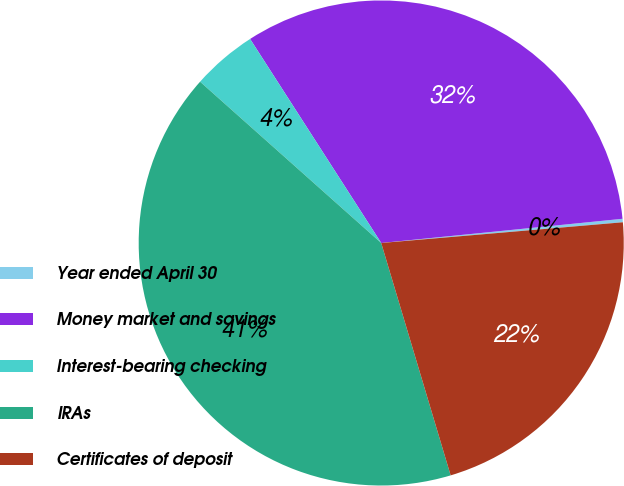Convert chart. <chart><loc_0><loc_0><loc_500><loc_500><pie_chart><fcel>Year ended April 30<fcel>Money market and savings<fcel>Interest-bearing checking<fcel>IRAs<fcel>Certificates of deposit<nl><fcel>0.23%<fcel>32.5%<fcel>4.33%<fcel>41.2%<fcel>21.74%<nl></chart> 